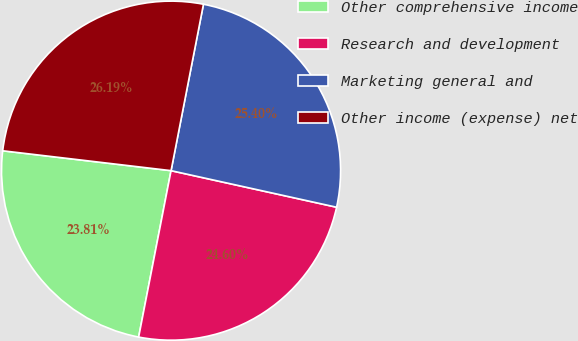<chart> <loc_0><loc_0><loc_500><loc_500><pie_chart><fcel>Other comprehensive income<fcel>Research and development<fcel>Marketing general and<fcel>Other income (expense) net<nl><fcel>23.81%<fcel>24.6%<fcel>25.4%<fcel>26.19%<nl></chart> 